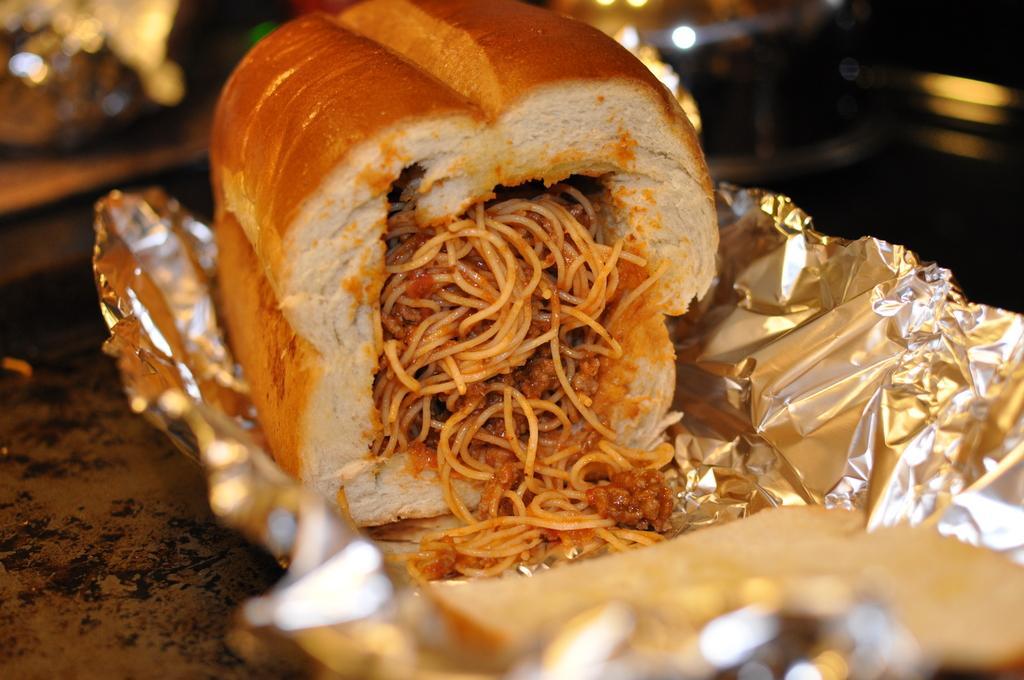Can you describe this image briefly? In this picture there is food on the silver wrapper. At the back the image is blurry. At the bottom it looks like a table. 